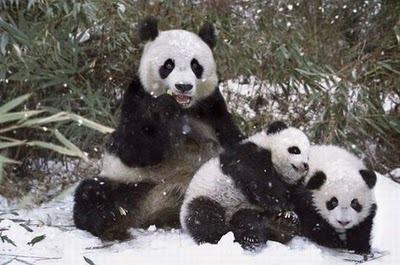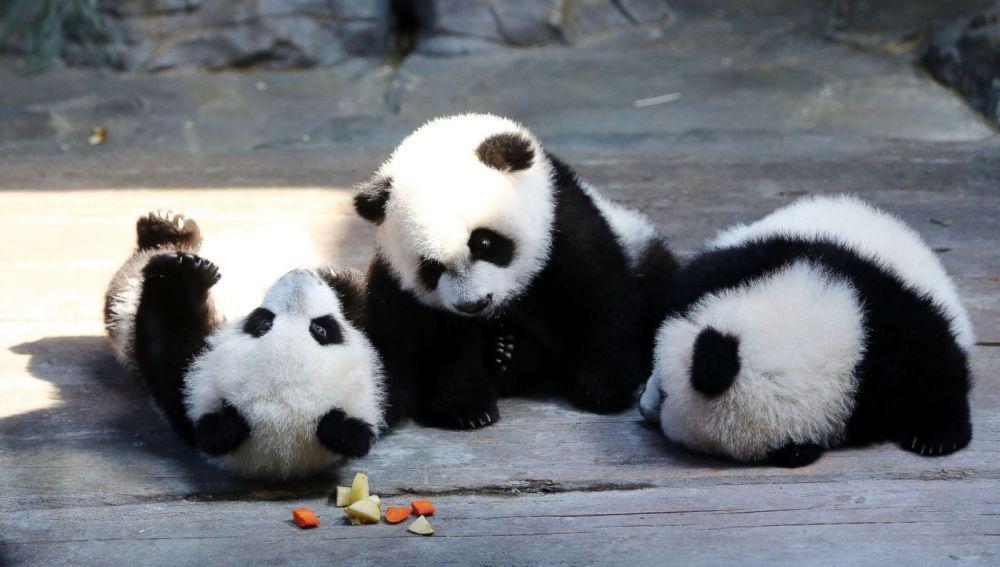The first image is the image on the left, the second image is the image on the right. For the images displayed, is the sentence "Each image shows a trio of pandas grouped closed together, and the right image shows pandas forming a pyramid shape on a ground of greenery." factually correct? Answer yes or no. No. The first image is the image on the left, the second image is the image on the right. Assess this claim about the two images: "There are atleast 2 pandas in a tree". Correct or not? Answer yes or no. No. 